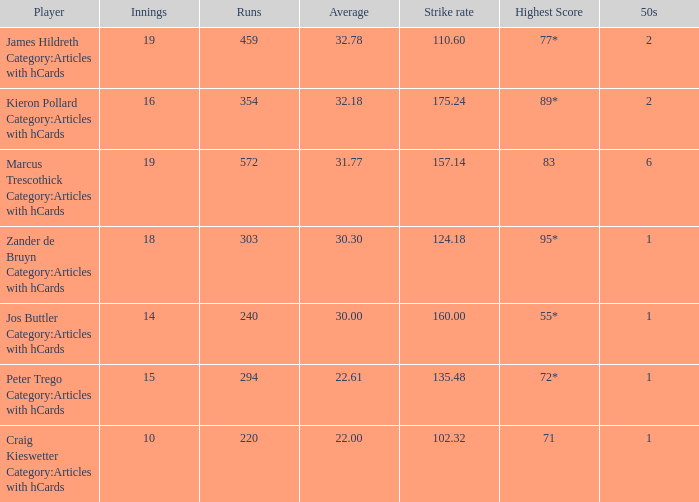What is the highest score for the player with average of 30.00? 55*. 